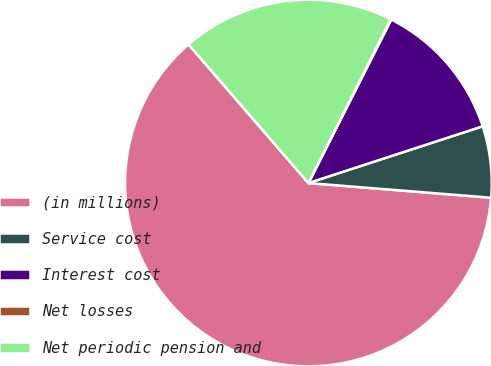Convert chart to OTSL. <chart><loc_0><loc_0><loc_500><loc_500><pie_chart><fcel>(in millions)<fcel>Service cost<fcel>Interest cost<fcel>Net losses<fcel>Net periodic pension and<nl><fcel>62.37%<fcel>6.29%<fcel>12.52%<fcel>0.06%<fcel>18.75%<nl></chart> 